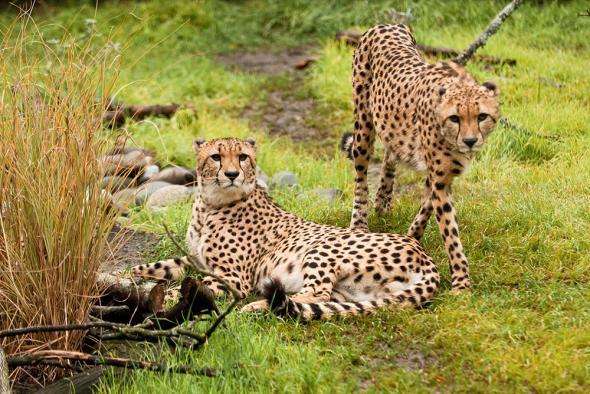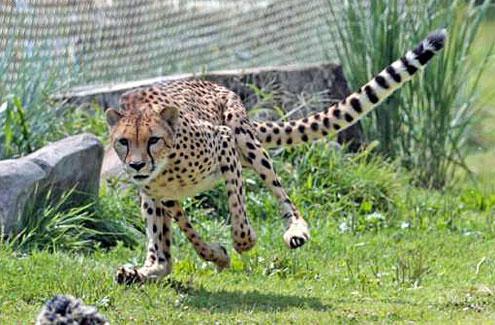The first image is the image on the left, the second image is the image on the right. Evaluate the accuracy of this statement regarding the images: "There are two leopards in one of the images.". Is it true? Answer yes or no. Yes. The first image is the image on the left, the second image is the image on the right. Examine the images to the left and right. Is the description "There are 3 cheetahs." accurate? Answer yes or no. Yes. 